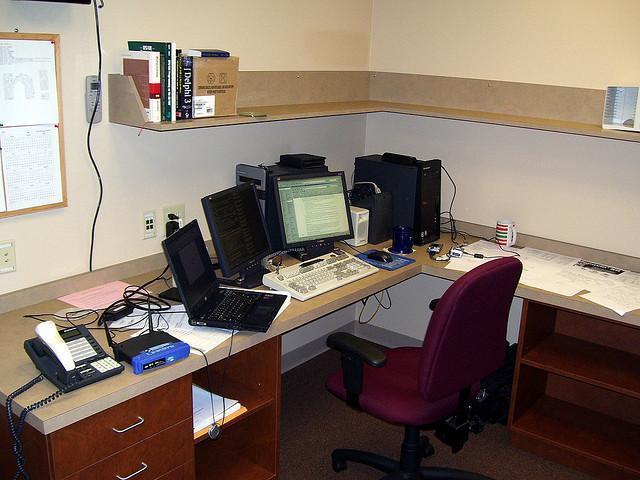How many books are in the room?
Give a very brief answer. 6. How many chairs can be seen?
Give a very brief answer. 1. 